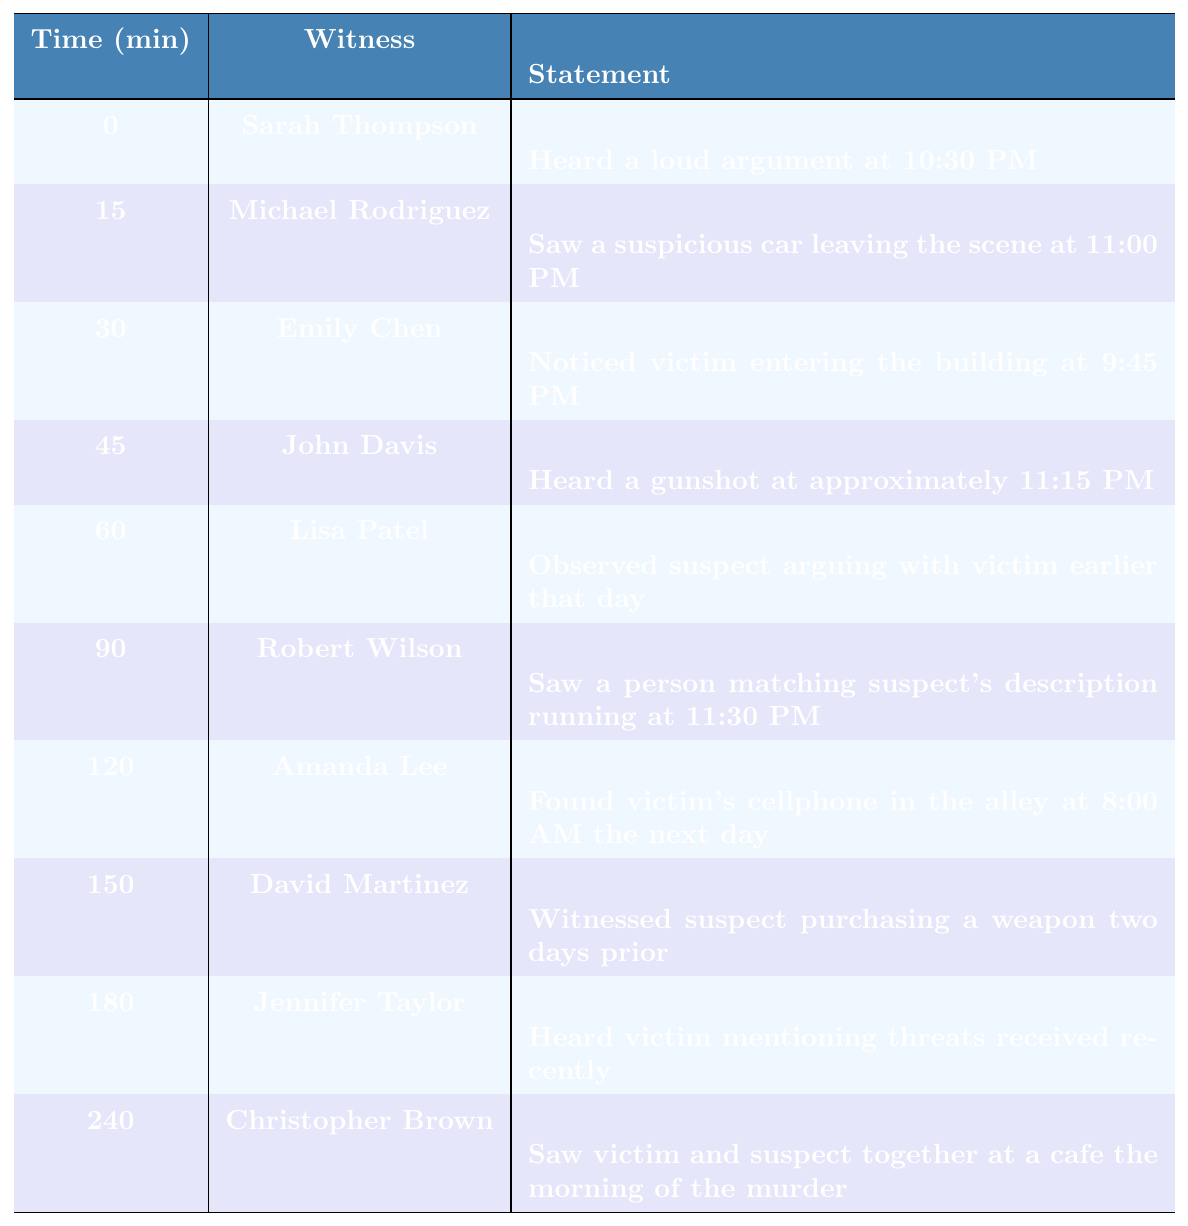What did Sarah Thompson hear? Sarah Thompson's statement in the table indicates that she heard a loud argument at 10:30 PM.
Answer: A loud argument at 10:30 PM At what time did Michael Rodriguez see the suspicious car? According to the table, Michael Rodriguez saw a suspicious car leaving the scene at 11:00 PM.
Answer: 11:00 PM How many minutes after Emily Chen's observation did John Davis hear the gunshot? Emily Chen made her observation at 9:45 PM (30 min = 9:45 PM) and John Davis heard the gunshot at approximately 11:15 PM (45 min = 11:15 PM). The difference is 45 min - 30 min = 15 min.
Answer: 15 minutes Did Lisa Patel observe the suspect and victim arguing earlier that day? The table shows that Lisa Patel observed the suspect arguing with the victim earlier that day, so the answer is yes.
Answer: Yes What is the time difference between Amanda Lee finding the victim's cellphone and Robert Wilson seeing the suspect running? Amanda Lee found the cellphone at 8:00 AM the next day (120 min = 8:00 AM) and Robert Wilson saw the suspect running at 11:30 PM (90 min = 11:30 PM). The difference is 120 min - 90 min = 30 min.
Answer: 30 minutes Which witness saw the victim and suspect together at a cafe? The table indicates that Christopher Brown saw the victim and suspect together at a cafe the morning of the murder.
Answer: Christopher Brown What was the first incident mentioned in the statements? The first incident recorded is Sarah Thompson's statement about hearing a loud argument at 10:30 PM, which is at time 0.
Answer: A loud argument How many witnesses mentioned events that occurred after 11:00 PM? The table shows John Davis, Robert Wilson, Amanda Lee, David Martinez, Jennifer Taylor, and Christopher Brown, with their statements at 45 min, 90 min, 120 min, 150 min, 180 min, and 240 min respectively. There are 6 witnesses whose statements are after 11:00 PM.
Answer: 6 witnesses What are the times of the statements involving the suspect? The statements involving the suspect are from Lisa Patel (60 min), Robert Wilson (90 min), David Martinez (150 min), and Christopher Brown (240 min).
Answer: 60 min, 90 min, 150 min, 240 min If we consider all statements, which witness had the longest wait time from the incident to their statement? The last relevant statement is from Amanda Lee, who found the victim's cellphone (120 min) after all other events, indicating she had the longest wait from the incident time the previous day.
Answer: Amanda Lee 